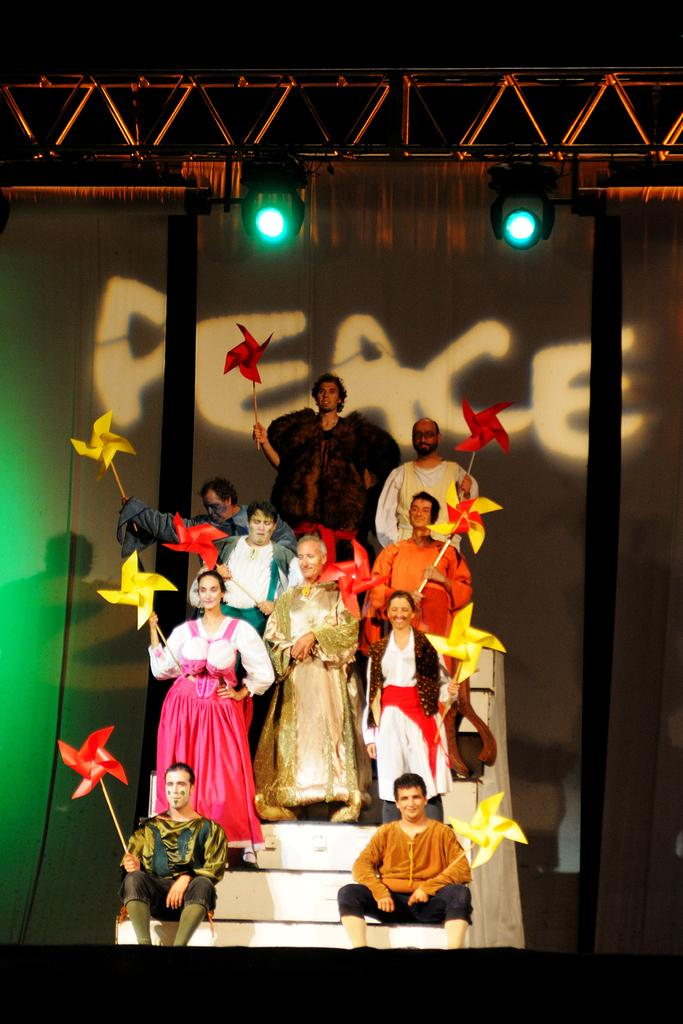What are the people in the image doing? There are people standing and sitting in the image. How are the people dressed? The people are wearing different dress in the image. What are the people holding in their hands? The people are holding red and yellow color fans in the image. What can be seen in the background of the image? There are lights and a screen visible in the background. What type of cabbage is being used as a hat by one of the people in the image? There is no cabbage present in the image, nor is anyone wearing a cabbage as a hat. What record is being played in the background of the image? There is no record player or music playing in the image; it only shows people standing and sitting with fans. 